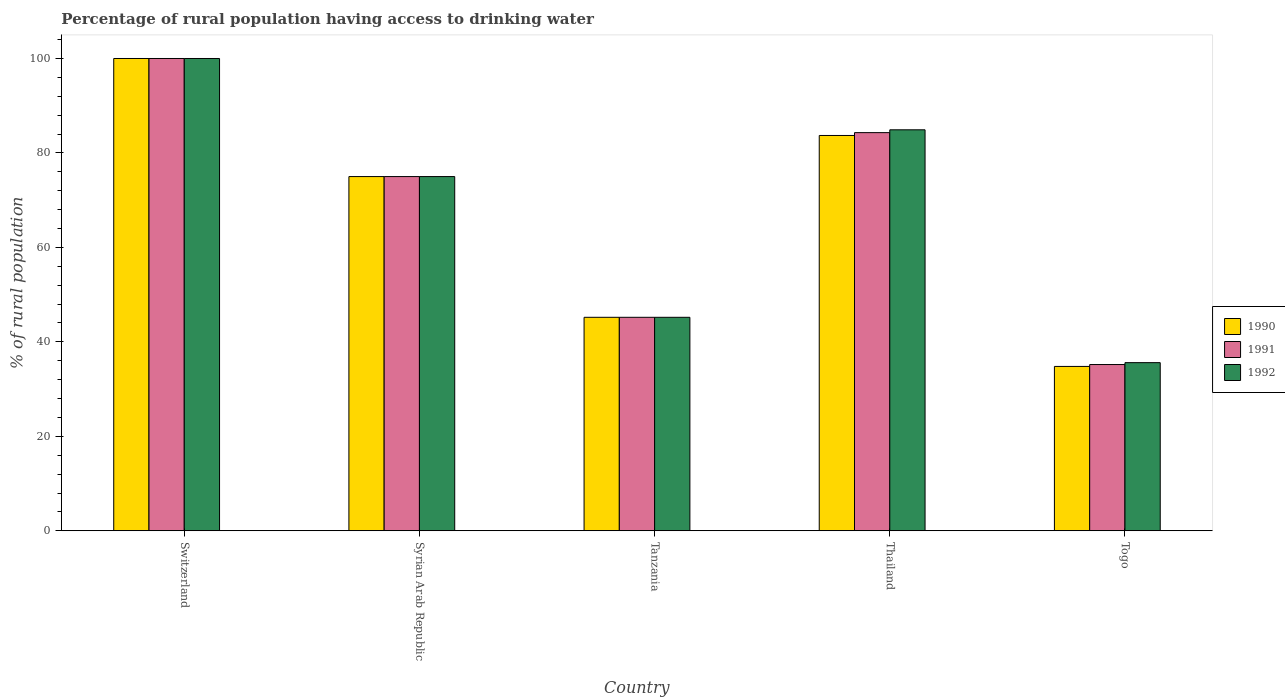Are the number of bars per tick equal to the number of legend labels?
Offer a very short reply. Yes. Are the number of bars on each tick of the X-axis equal?
Your answer should be compact. Yes. How many bars are there on the 2nd tick from the left?
Your answer should be very brief. 3. What is the label of the 5th group of bars from the left?
Your answer should be very brief. Togo. What is the percentage of rural population having access to drinking water in 1991 in Togo?
Ensure brevity in your answer.  35.2. Across all countries, what is the maximum percentage of rural population having access to drinking water in 1992?
Provide a short and direct response. 100. Across all countries, what is the minimum percentage of rural population having access to drinking water in 1992?
Make the answer very short. 35.6. In which country was the percentage of rural population having access to drinking water in 1992 maximum?
Make the answer very short. Switzerland. In which country was the percentage of rural population having access to drinking water in 1991 minimum?
Offer a terse response. Togo. What is the total percentage of rural population having access to drinking water in 1991 in the graph?
Offer a terse response. 339.7. What is the difference between the percentage of rural population having access to drinking water in 1991 in Syrian Arab Republic and that in Togo?
Provide a succinct answer. 39.8. What is the difference between the percentage of rural population having access to drinking water in 1992 in Syrian Arab Republic and the percentage of rural population having access to drinking water in 1990 in Thailand?
Provide a succinct answer. -8.7. What is the average percentage of rural population having access to drinking water in 1992 per country?
Offer a terse response. 68.14. What is the difference between the percentage of rural population having access to drinking water of/in 1992 and percentage of rural population having access to drinking water of/in 1990 in Togo?
Ensure brevity in your answer.  0.8. What is the ratio of the percentage of rural population having access to drinking water in 1990 in Switzerland to that in Tanzania?
Provide a succinct answer. 2.21. Is the difference between the percentage of rural population having access to drinking water in 1992 in Switzerland and Togo greater than the difference between the percentage of rural population having access to drinking water in 1990 in Switzerland and Togo?
Ensure brevity in your answer.  No. What is the difference between the highest and the second highest percentage of rural population having access to drinking water in 1990?
Give a very brief answer. -8.7. What is the difference between the highest and the lowest percentage of rural population having access to drinking water in 1990?
Offer a terse response. 65.2. In how many countries, is the percentage of rural population having access to drinking water in 1992 greater than the average percentage of rural population having access to drinking water in 1992 taken over all countries?
Offer a very short reply. 3. What does the 1st bar from the left in Thailand represents?
Ensure brevity in your answer.  1990. What does the 1st bar from the right in Syrian Arab Republic represents?
Provide a short and direct response. 1992. Are all the bars in the graph horizontal?
Ensure brevity in your answer.  No. How many countries are there in the graph?
Ensure brevity in your answer.  5. What is the difference between two consecutive major ticks on the Y-axis?
Keep it short and to the point. 20. What is the title of the graph?
Make the answer very short. Percentage of rural population having access to drinking water. Does "1972" appear as one of the legend labels in the graph?
Make the answer very short. No. What is the label or title of the X-axis?
Ensure brevity in your answer.  Country. What is the label or title of the Y-axis?
Keep it short and to the point. % of rural population. What is the % of rural population of 1990 in Switzerland?
Offer a terse response. 100. What is the % of rural population of 1991 in Switzerland?
Make the answer very short. 100. What is the % of rural population of 1990 in Syrian Arab Republic?
Ensure brevity in your answer.  75. What is the % of rural population of 1991 in Syrian Arab Republic?
Your answer should be very brief. 75. What is the % of rural population in 1992 in Syrian Arab Republic?
Your answer should be compact. 75. What is the % of rural population of 1990 in Tanzania?
Give a very brief answer. 45.2. What is the % of rural population in 1991 in Tanzania?
Provide a short and direct response. 45.2. What is the % of rural population in 1992 in Tanzania?
Your answer should be compact. 45.2. What is the % of rural population of 1990 in Thailand?
Offer a terse response. 83.7. What is the % of rural population of 1991 in Thailand?
Your response must be concise. 84.3. What is the % of rural population in 1992 in Thailand?
Make the answer very short. 84.9. What is the % of rural population in 1990 in Togo?
Your response must be concise. 34.8. What is the % of rural population of 1991 in Togo?
Keep it short and to the point. 35.2. What is the % of rural population of 1992 in Togo?
Provide a succinct answer. 35.6. Across all countries, what is the maximum % of rural population of 1990?
Give a very brief answer. 100. Across all countries, what is the minimum % of rural population of 1990?
Provide a succinct answer. 34.8. Across all countries, what is the minimum % of rural population in 1991?
Ensure brevity in your answer.  35.2. Across all countries, what is the minimum % of rural population of 1992?
Offer a very short reply. 35.6. What is the total % of rural population in 1990 in the graph?
Provide a short and direct response. 338.7. What is the total % of rural population in 1991 in the graph?
Offer a very short reply. 339.7. What is the total % of rural population of 1992 in the graph?
Your response must be concise. 340.7. What is the difference between the % of rural population of 1991 in Switzerland and that in Syrian Arab Republic?
Your response must be concise. 25. What is the difference between the % of rural population of 1992 in Switzerland and that in Syrian Arab Republic?
Ensure brevity in your answer.  25. What is the difference between the % of rural population in 1990 in Switzerland and that in Tanzania?
Your answer should be very brief. 54.8. What is the difference between the % of rural population of 1991 in Switzerland and that in Tanzania?
Your response must be concise. 54.8. What is the difference between the % of rural population in 1992 in Switzerland and that in Tanzania?
Give a very brief answer. 54.8. What is the difference between the % of rural population of 1990 in Switzerland and that in Thailand?
Your answer should be very brief. 16.3. What is the difference between the % of rural population of 1991 in Switzerland and that in Thailand?
Offer a terse response. 15.7. What is the difference between the % of rural population of 1992 in Switzerland and that in Thailand?
Offer a very short reply. 15.1. What is the difference between the % of rural population of 1990 in Switzerland and that in Togo?
Your answer should be very brief. 65.2. What is the difference between the % of rural population in 1991 in Switzerland and that in Togo?
Your response must be concise. 64.8. What is the difference between the % of rural population in 1992 in Switzerland and that in Togo?
Offer a very short reply. 64.4. What is the difference between the % of rural population in 1990 in Syrian Arab Republic and that in Tanzania?
Offer a very short reply. 29.8. What is the difference between the % of rural population of 1991 in Syrian Arab Republic and that in Tanzania?
Offer a very short reply. 29.8. What is the difference between the % of rural population in 1992 in Syrian Arab Republic and that in Tanzania?
Your response must be concise. 29.8. What is the difference between the % of rural population in 1990 in Syrian Arab Republic and that in Thailand?
Your answer should be very brief. -8.7. What is the difference between the % of rural population in 1991 in Syrian Arab Republic and that in Thailand?
Keep it short and to the point. -9.3. What is the difference between the % of rural population in 1990 in Syrian Arab Republic and that in Togo?
Your answer should be very brief. 40.2. What is the difference between the % of rural population in 1991 in Syrian Arab Republic and that in Togo?
Ensure brevity in your answer.  39.8. What is the difference between the % of rural population of 1992 in Syrian Arab Republic and that in Togo?
Keep it short and to the point. 39.4. What is the difference between the % of rural population in 1990 in Tanzania and that in Thailand?
Keep it short and to the point. -38.5. What is the difference between the % of rural population in 1991 in Tanzania and that in Thailand?
Your response must be concise. -39.1. What is the difference between the % of rural population in 1992 in Tanzania and that in Thailand?
Your response must be concise. -39.7. What is the difference between the % of rural population in 1990 in Tanzania and that in Togo?
Give a very brief answer. 10.4. What is the difference between the % of rural population in 1990 in Thailand and that in Togo?
Your response must be concise. 48.9. What is the difference between the % of rural population of 1991 in Thailand and that in Togo?
Provide a short and direct response. 49.1. What is the difference between the % of rural population in 1992 in Thailand and that in Togo?
Make the answer very short. 49.3. What is the difference between the % of rural population of 1990 in Switzerland and the % of rural population of 1991 in Tanzania?
Your response must be concise. 54.8. What is the difference between the % of rural population of 1990 in Switzerland and the % of rural population of 1992 in Tanzania?
Offer a terse response. 54.8. What is the difference between the % of rural population of 1991 in Switzerland and the % of rural population of 1992 in Tanzania?
Your answer should be compact. 54.8. What is the difference between the % of rural population of 1990 in Switzerland and the % of rural population of 1991 in Togo?
Make the answer very short. 64.8. What is the difference between the % of rural population in 1990 in Switzerland and the % of rural population in 1992 in Togo?
Provide a succinct answer. 64.4. What is the difference between the % of rural population in 1991 in Switzerland and the % of rural population in 1992 in Togo?
Ensure brevity in your answer.  64.4. What is the difference between the % of rural population of 1990 in Syrian Arab Republic and the % of rural population of 1991 in Tanzania?
Your answer should be very brief. 29.8. What is the difference between the % of rural population in 1990 in Syrian Arab Republic and the % of rural population in 1992 in Tanzania?
Make the answer very short. 29.8. What is the difference between the % of rural population of 1991 in Syrian Arab Republic and the % of rural population of 1992 in Tanzania?
Your response must be concise. 29.8. What is the difference between the % of rural population of 1991 in Syrian Arab Republic and the % of rural population of 1992 in Thailand?
Provide a short and direct response. -9.9. What is the difference between the % of rural population of 1990 in Syrian Arab Republic and the % of rural population of 1991 in Togo?
Give a very brief answer. 39.8. What is the difference between the % of rural population of 1990 in Syrian Arab Republic and the % of rural population of 1992 in Togo?
Make the answer very short. 39.4. What is the difference between the % of rural population of 1991 in Syrian Arab Republic and the % of rural population of 1992 in Togo?
Provide a short and direct response. 39.4. What is the difference between the % of rural population of 1990 in Tanzania and the % of rural population of 1991 in Thailand?
Your answer should be very brief. -39.1. What is the difference between the % of rural population of 1990 in Tanzania and the % of rural population of 1992 in Thailand?
Offer a very short reply. -39.7. What is the difference between the % of rural population in 1991 in Tanzania and the % of rural population in 1992 in Thailand?
Provide a succinct answer. -39.7. What is the difference between the % of rural population of 1990 in Tanzania and the % of rural population of 1992 in Togo?
Offer a terse response. 9.6. What is the difference between the % of rural population in 1991 in Tanzania and the % of rural population in 1992 in Togo?
Keep it short and to the point. 9.6. What is the difference between the % of rural population in 1990 in Thailand and the % of rural population in 1991 in Togo?
Provide a short and direct response. 48.5. What is the difference between the % of rural population in 1990 in Thailand and the % of rural population in 1992 in Togo?
Offer a terse response. 48.1. What is the difference between the % of rural population of 1991 in Thailand and the % of rural population of 1992 in Togo?
Provide a short and direct response. 48.7. What is the average % of rural population in 1990 per country?
Give a very brief answer. 67.74. What is the average % of rural population of 1991 per country?
Give a very brief answer. 67.94. What is the average % of rural population in 1992 per country?
Ensure brevity in your answer.  68.14. What is the difference between the % of rural population in 1991 and % of rural population in 1992 in Switzerland?
Offer a terse response. 0. What is the difference between the % of rural population in 1990 and % of rural population in 1992 in Syrian Arab Republic?
Your answer should be very brief. 0. What is the difference between the % of rural population in 1991 and % of rural population in 1992 in Syrian Arab Republic?
Provide a short and direct response. 0. What is the difference between the % of rural population of 1990 and % of rural population of 1991 in Tanzania?
Keep it short and to the point. 0. What is the difference between the % of rural population in 1990 and % of rural population in 1992 in Tanzania?
Provide a short and direct response. 0. What is the difference between the % of rural population of 1991 and % of rural population of 1992 in Tanzania?
Offer a very short reply. 0. What is the ratio of the % of rural population in 1990 in Switzerland to that in Syrian Arab Republic?
Your answer should be compact. 1.33. What is the ratio of the % of rural population in 1991 in Switzerland to that in Syrian Arab Republic?
Give a very brief answer. 1.33. What is the ratio of the % of rural population of 1990 in Switzerland to that in Tanzania?
Offer a terse response. 2.21. What is the ratio of the % of rural population of 1991 in Switzerland to that in Tanzania?
Make the answer very short. 2.21. What is the ratio of the % of rural population in 1992 in Switzerland to that in Tanzania?
Give a very brief answer. 2.21. What is the ratio of the % of rural population in 1990 in Switzerland to that in Thailand?
Provide a short and direct response. 1.19. What is the ratio of the % of rural population of 1991 in Switzerland to that in Thailand?
Keep it short and to the point. 1.19. What is the ratio of the % of rural population in 1992 in Switzerland to that in Thailand?
Make the answer very short. 1.18. What is the ratio of the % of rural population of 1990 in Switzerland to that in Togo?
Offer a terse response. 2.87. What is the ratio of the % of rural population in 1991 in Switzerland to that in Togo?
Your answer should be compact. 2.84. What is the ratio of the % of rural population in 1992 in Switzerland to that in Togo?
Make the answer very short. 2.81. What is the ratio of the % of rural population of 1990 in Syrian Arab Republic to that in Tanzania?
Keep it short and to the point. 1.66. What is the ratio of the % of rural population in 1991 in Syrian Arab Republic to that in Tanzania?
Your answer should be very brief. 1.66. What is the ratio of the % of rural population in 1992 in Syrian Arab Republic to that in Tanzania?
Provide a succinct answer. 1.66. What is the ratio of the % of rural population in 1990 in Syrian Arab Republic to that in Thailand?
Give a very brief answer. 0.9. What is the ratio of the % of rural population of 1991 in Syrian Arab Republic to that in Thailand?
Offer a very short reply. 0.89. What is the ratio of the % of rural population of 1992 in Syrian Arab Republic to that in Thailand?
Keep it short and to the point. 0.88. What is the ratio of the % of rural population in 1990 in Syrian Arab Republic to that in Togo?
Your response must be concise. 2.16. What is the ratio of the % of rural population of 1991 in Syrian Arab Republic to that in Togo?
Offer a terse response. 2.13. What is the ratio of the % of rural population of 1992 in Syrian Arab Republic to that in Togo?
Your answer should be compact. 2.11. What is the ratio of the % of rural population of 1990 in Tanzania to that in Thailand?
Provide a succinct answer. 0.54. What is the ratio of the % of rural population in 1991 in Tanzania to that in Thailand?
Offer a very short reply. 0.54. What is the ratio of the % of rural population of 1992 in Tanzania to that in Thailand?
Keep it short and to the point. 0.53. What is the ratio of the % of rural population in 1990 in Tanzania to that in Togo?
Your response must be concise. 1.3. What is the ratio of the % of rural population in 1991 in Tanzania to that in Togo?
Provide a short and direct response. 1.28. What is the ratio of the % of rural population of 1992 in Tanzania to that in Togo?
Keep it short and to the point. 1.27. What is the ratio of the % of rural population of 1990 in Thailand to that in Togo?
Your answer should be very brief. 2.41. What is the ratio of the % of rural population in 1991 in Thailand to that in Togo?
Offer a terse response. 2.39. What is the ratio of the % of rural population of 1992 in Thailand to that in Togo?
Provide a short and direct response. 2.38. What is the difference between the highest and the lowest % of rural population in 1990?
Keep it short and to the point. 65.2. What is the difference between the highest and the lowest % of rural population of 1991?
Offer a very short reply. 64.8. What is the difference between the highest and the lowest % of rural population in 1992?
Offer a very short reply. 64.4. 